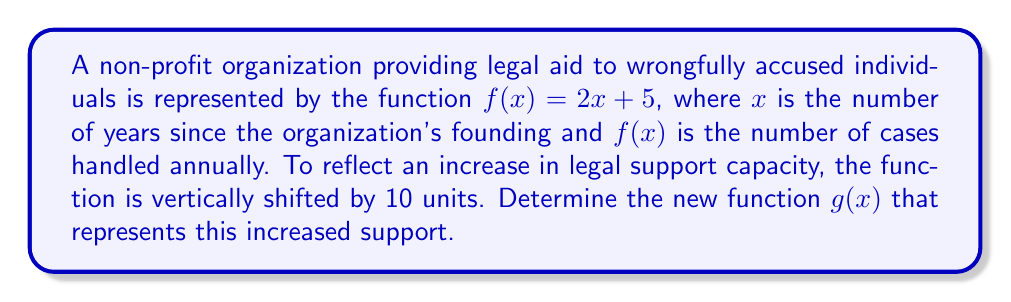Help me with this question. To solve this problem, we need to understand vertical shifts in functions:

1. The original function is $f(x) = 2x + 5$

2. A vertical shift of a function is achieved by adding or subtracting a constant to the entire function.

3. In this case, we're increasing the function by 10 units, which means we're shifting it up.

4. To shift a function up by 10 units, we add 10 to the original function:

   $g(x) = f(x) + 10$

5. Substituting the original function:

   $g(x) = (2x + 5) + 10$

6. Simplifying:

   $g(x) = 2x + 15$

Therefore, the new function $g(x)$ that represents the increased legal support is $g(x) = 2x + 15$.
Answer: $g(x) = 2x + 15$ 